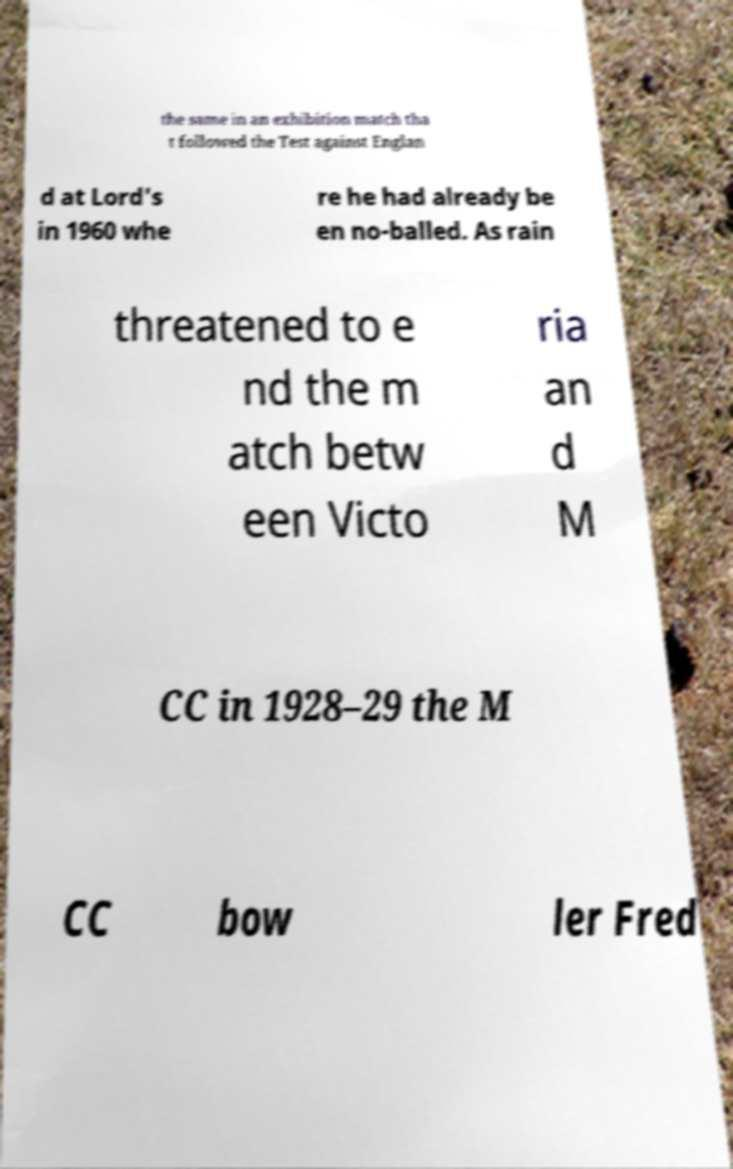Can you accurately transcribe the text from the provided image for me? the same in an exhibition match tha t followed the Test against Englan d at Lord's in 1960 whe re he had already be en no-balled. As rain threatened to e nd the m atch betw een Victo ria an d M CC in 1928–29 the M CC bow ler Fred 